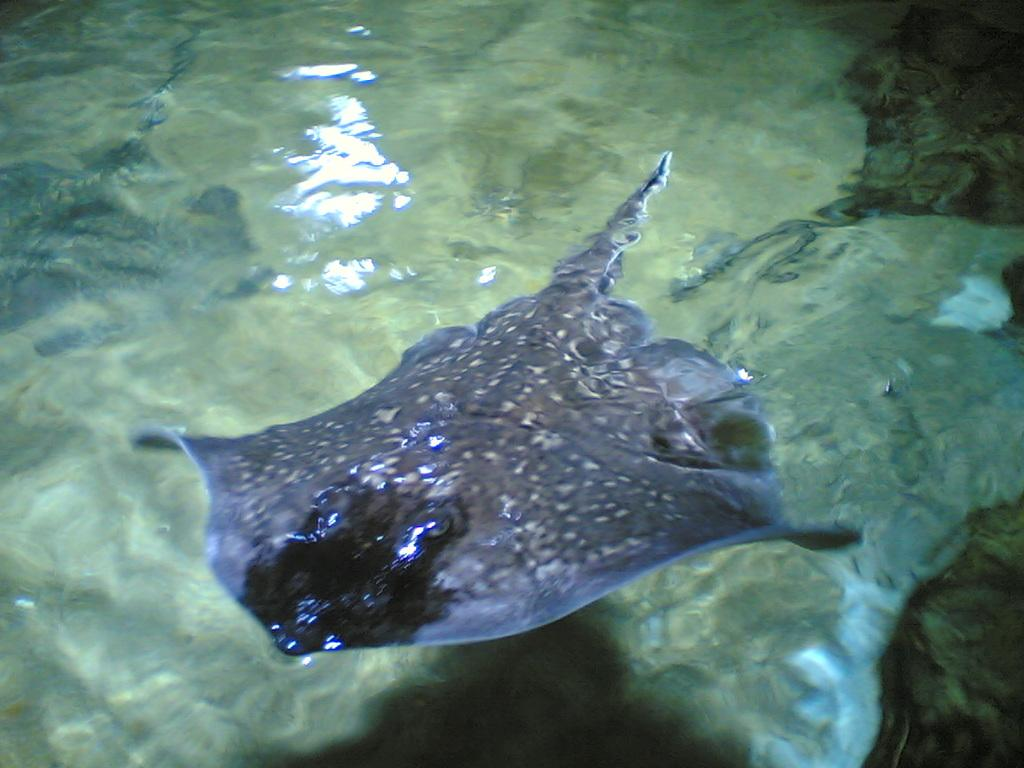What is the main subject in the foreground of the image? There is a fish in the foreground area of the image. Can you describe the environment where the fish is located? The fish is in the water. What type of stitch is being used to sew the fish on the stage? There is no stitch or stage present in the image; it features a fish in the water. 